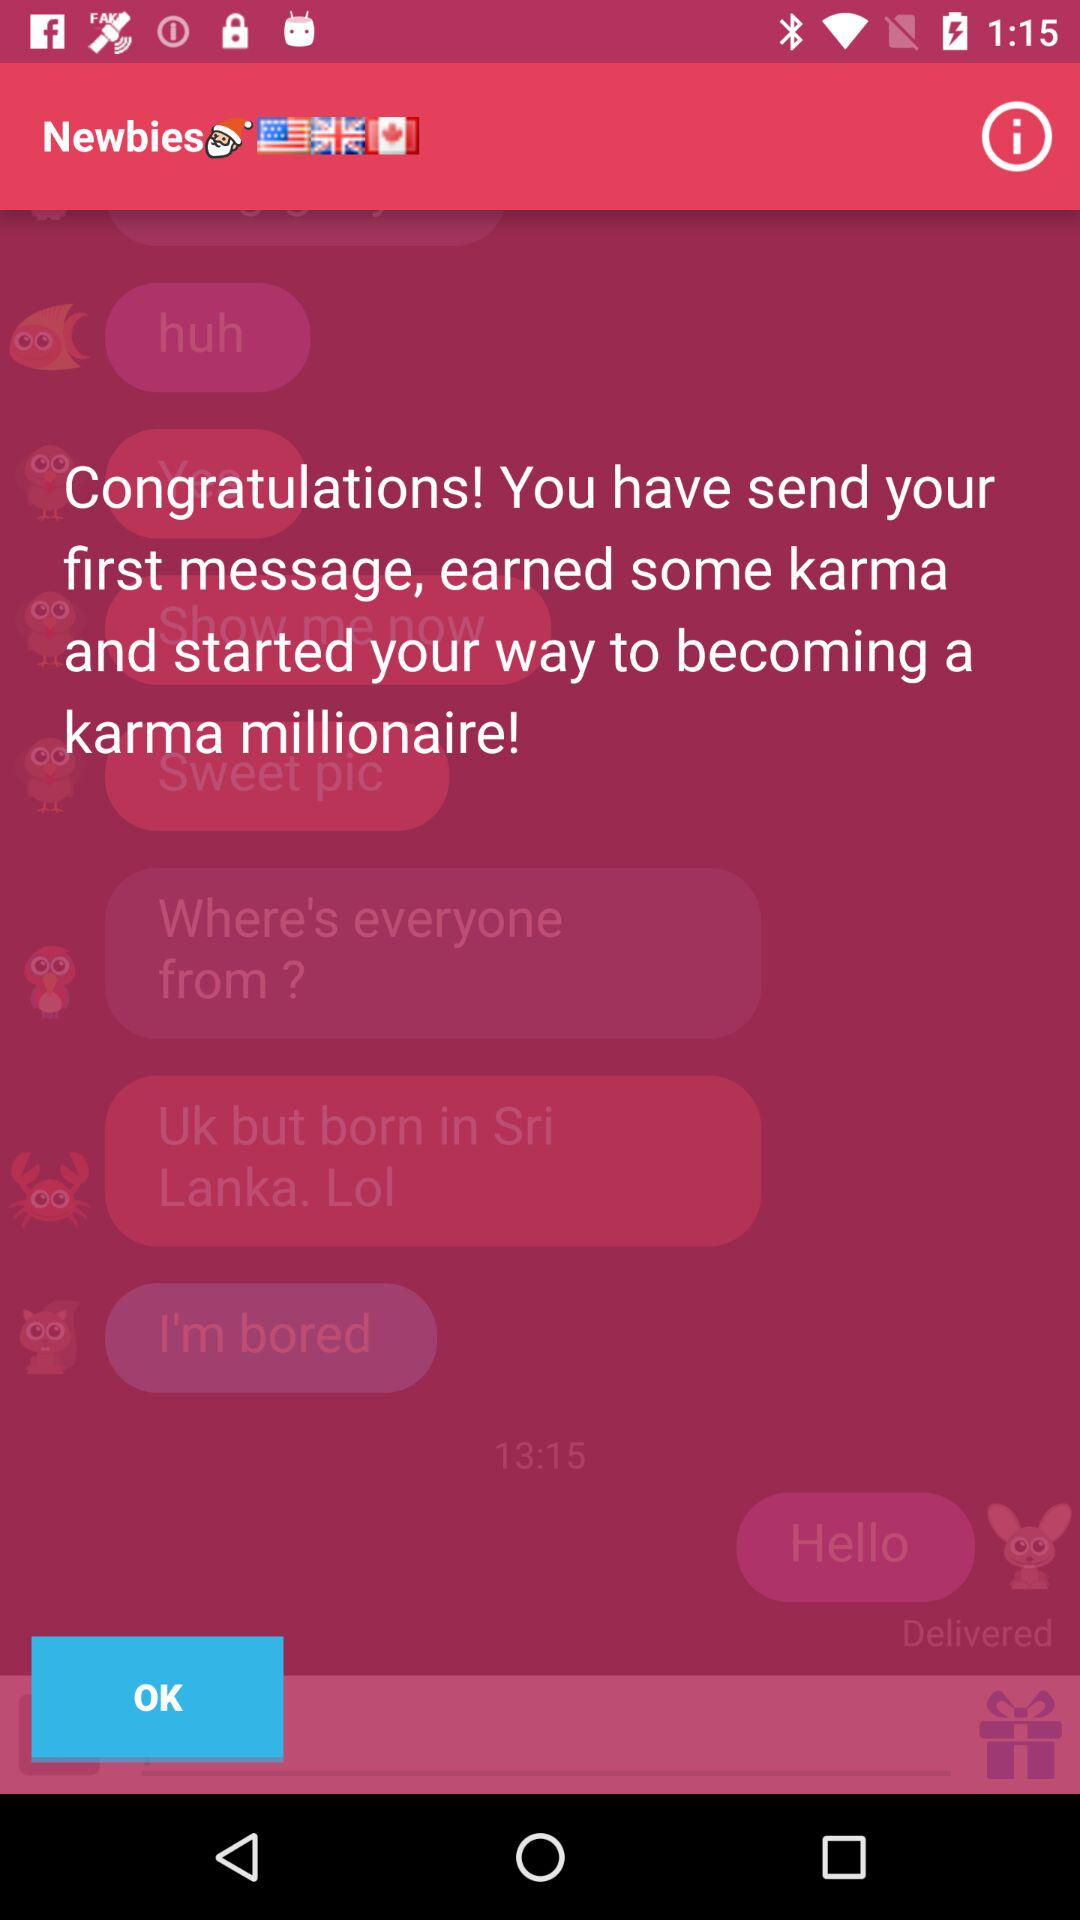How many text messages have been sent?
Answer the question using a single word or phrase. 1 